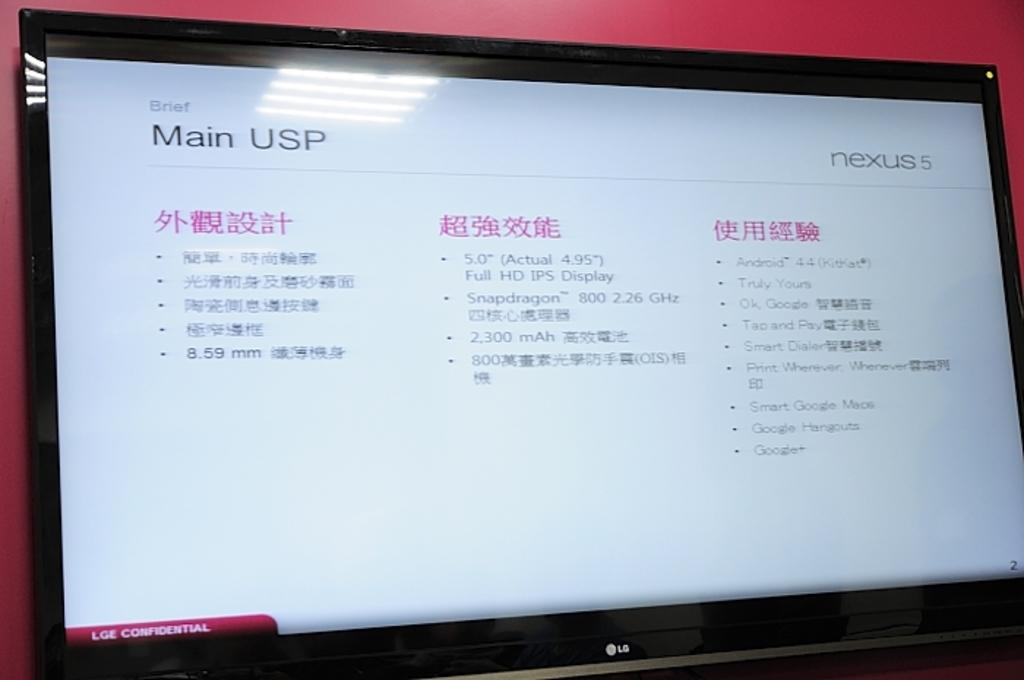<image>
Describe the image concisely. An LG screen shows us the Main USP along with some foreign text. 